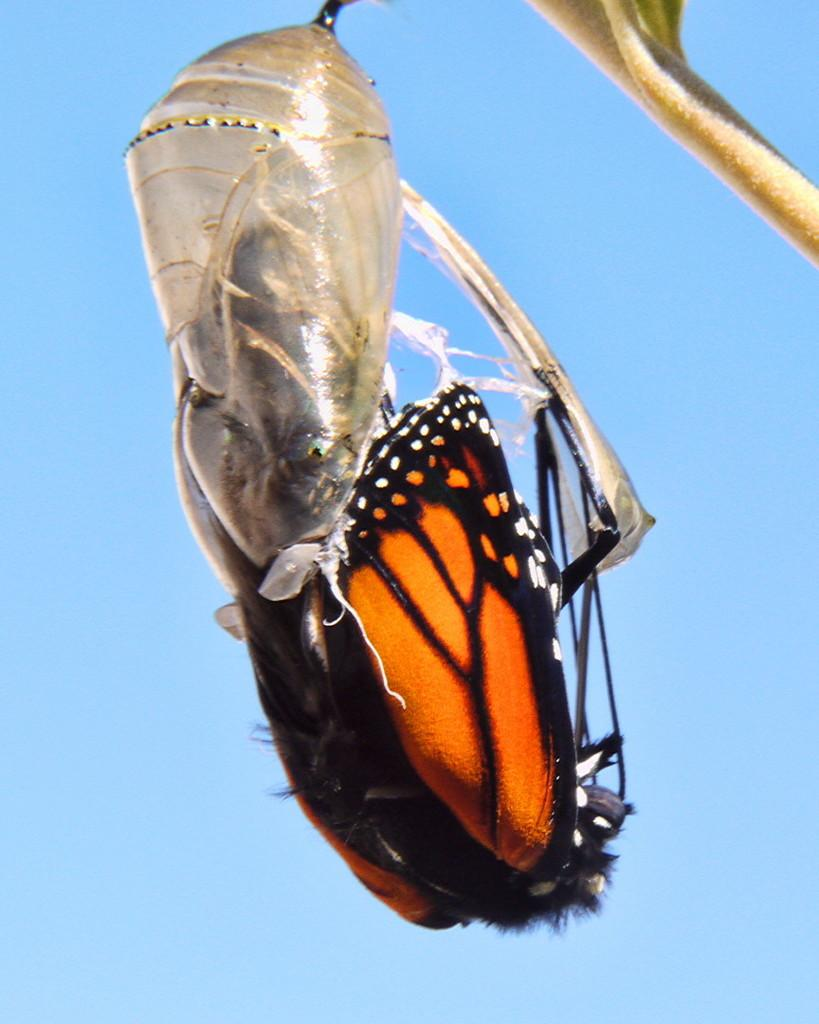What is the main subject of the image? The main subject of the image is a butterfly. What stage of the butterfly's life cycle is depicted in the image? The butterfly is coming out of a pupa. What color is the background of the image? The background of the image is blue. How many parcels can be seen in the image? There are no parcels present in the image. Is there a river visible in the background of the image? There is no river visible in the image; the background is blue. 